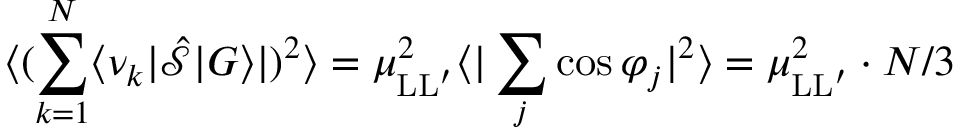<formula> <loc_0><loc_0><loc_500><loc_500>\langle ( \sum _ { k = 1 } ^ { N } \langle \nu _ { k } | \hat { \mathcal { S } } | G \rangle | ) ^ { 2 } \rangle = \mu _ { L L ^ { \prime } } ^ { 2 } \langle | \sum _ { j } \cos \varphi _ { j } | ^ { 2 } \rangle = \mu _ { L L ^ { \prime } } ^ { 2 } \cdot N / 3</formula> 